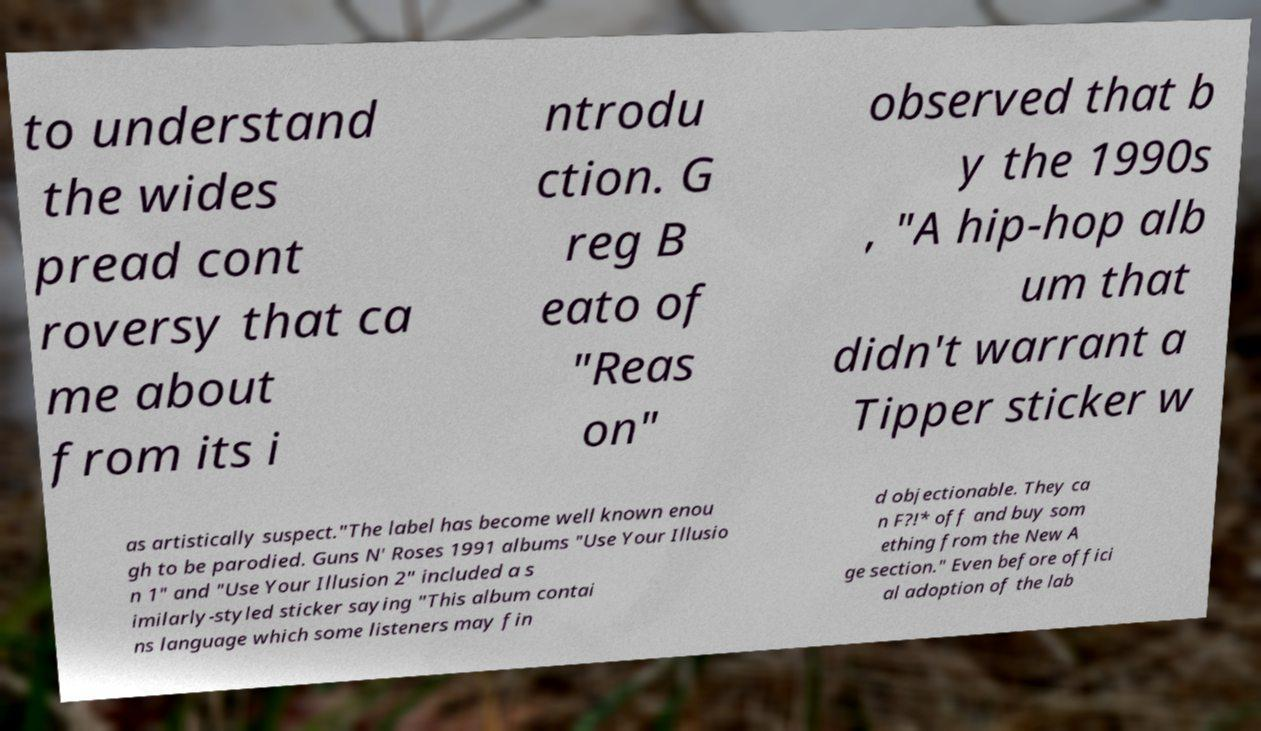What messages or text are displayed in this image? I need them in a readable, typed format. to understand the wides pread cont roversy that ca me about from its i ntrodu ction. G reg B eato of "Reas on" observed that b y the 1990s , "A hip-hop alb um that didn't warrant a Tipper sticker w as artistically suspect."The label has become well known enou gh to be parodied. Guns N' Roses 1991 albums "Use Your Illusio n 1" and "Use Your Illusion 2" included a s imilarly-styled sticker saying "This album contai ns language which some listeners may fin d objectionable. They ca n F?!* off and buy som ething from the New A ge section." Even before offici al adoption of the lab 